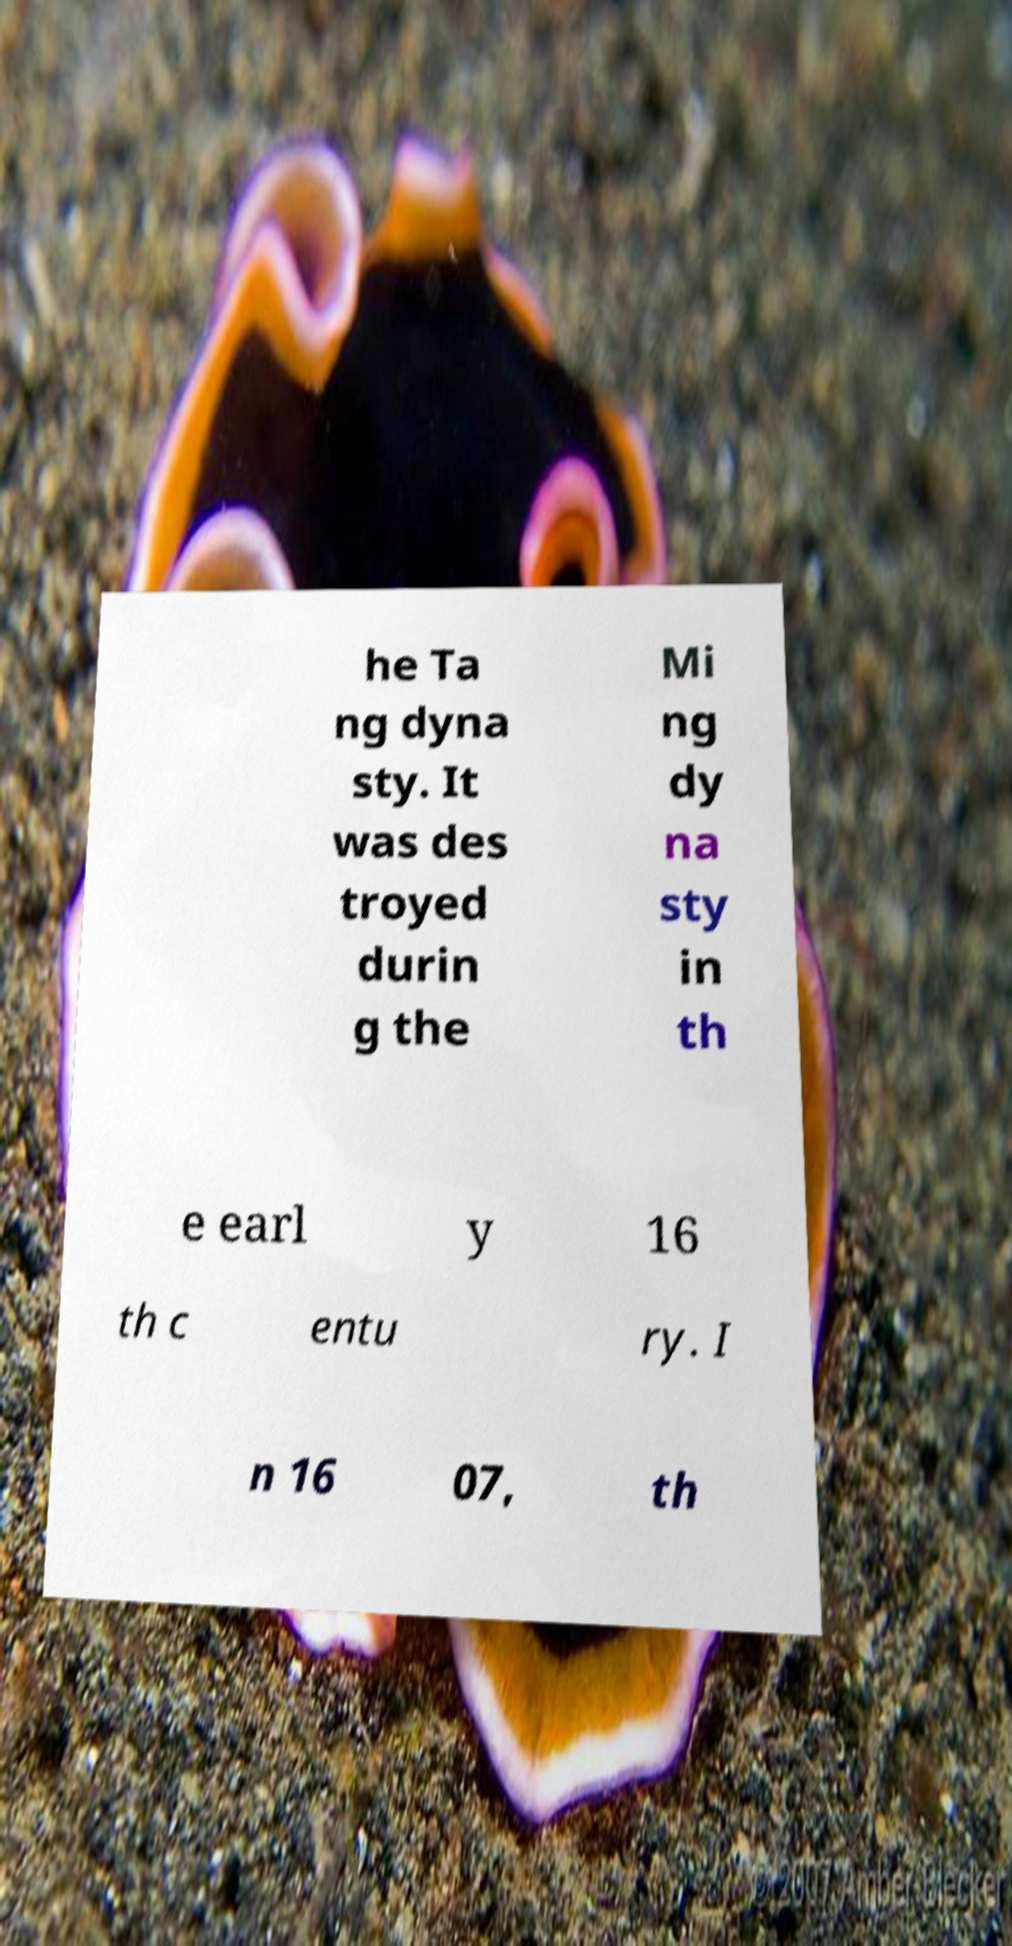I need the written content from this picture converted into text. Can you do that? he Ta ng dyna sty. It was des troyed durin g the Mi ng dy na sty in th e earl y 16 th c entu ry. I n 16 07, th 